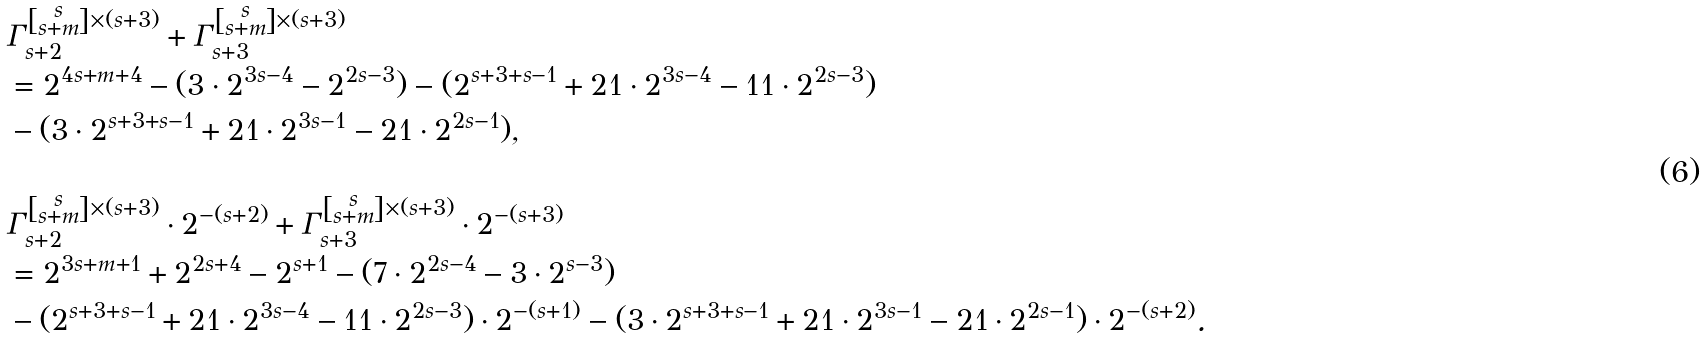Convert formula to latex. <formula><loc_0><loc_0><loc_500><loc_500>& \Gamma _ { s + 2 } ^ { \left [ \substack { s \\ s + m } \right ] \times ( s + 3 ) } + \Gamma _ { s + 3 } ^ { \left [ \substack { s \\ s + m } \right ] \times ( s + 3 ) } \\ & = 2 ^ { 4 s + m + 4 } - ( 3 \cdot 2 ^ { 3 s - 4 } - 2 ^ { 2 s - 3 } ) - ( 2 ^ { s + 3 + s - 1 } + 2 1 \cdot 2 ^ { 3 s - 4 } - 1 1 \cdot 2 ^ { 2 s - 3 } ) \\ & - ( 3 \cdot 2 ^ { s + 3 + s - 1 } + 2 1 \cdot 2 ^ { 3 s - 1 } - 2 1 \cdot 2 ^ { 2 s - 1 } ) , \\ & \\ & \Gamma _ { s + 2 } ^ { \left [ \substack { s \\ s + m } \right ] \times ( s + 3 ) } \cdot 2 ^ { - ( s + 2 ) } + \Gamma _ { s + 3 } ^ { \left [ \substack { s \\ s + m } \right ] \times ( s + 3 ) } \cdot 2 ^ { - ( s + 3 ) } \\ & = 2 ^ { 3 s + m + 1 } + 2 ^ { 2 s + 4 } - 2 ^ { s + 1 } - ( 7 \cdot 2 ^ { 2 s - 4 } - 3 \cdot 2 ^ { s - 3 } ) \\ & - ( 2 ^ { s + 3 + s - 1 } + 2 1 \cdot 2 ^ { 3 s - 4 } - 1 1 \cdot 2 ^ { 2 s - 3 } ) \cdot 2 ^ { - ( s + 1 ) } - ( 3 \cdot 2 ^ { s + 3 + s - 1 } + 2 1 \cdot 2 ^ { 3 s - 1 } - 2 1 \cdot 2 ^ { 2 s - 1 } ) \cdot 2 ^ { - ( s + 2 ) } .</formula> 